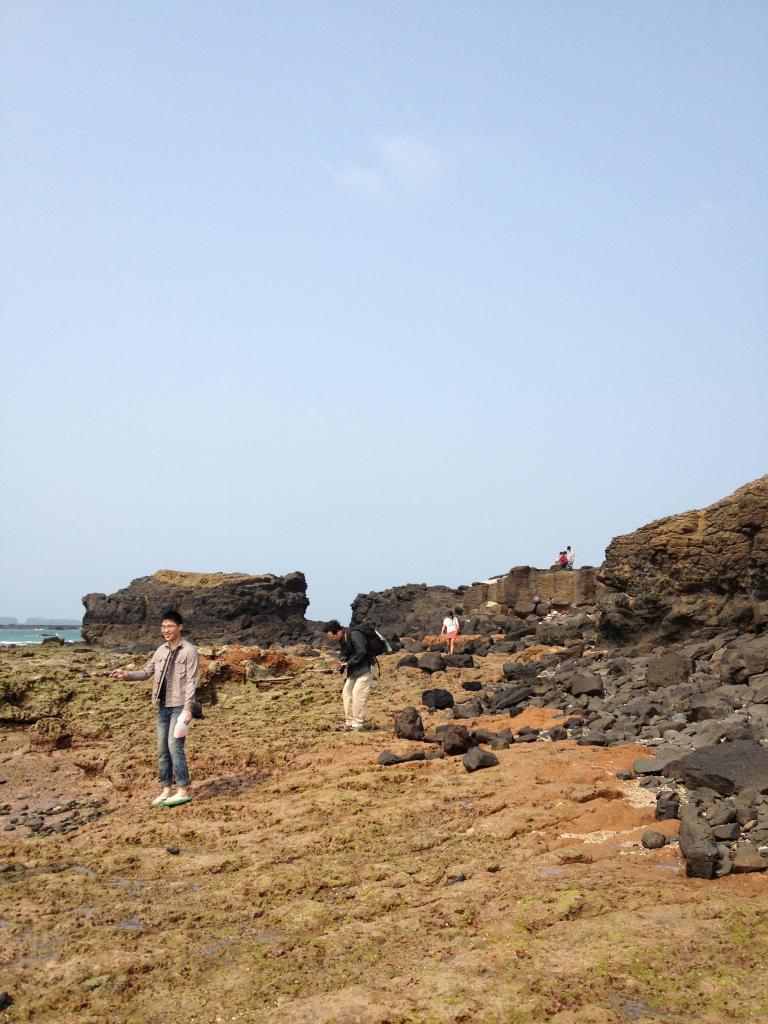How would you summarize this image in a sentence or two? The picture is taken in a hilly area. In the foreground of the picture there is soil. In the center of the picture there are rocks, soil and people. In the background there are two people sitting on a rock. On the left it is looking like a water body. At the top it is sky. 